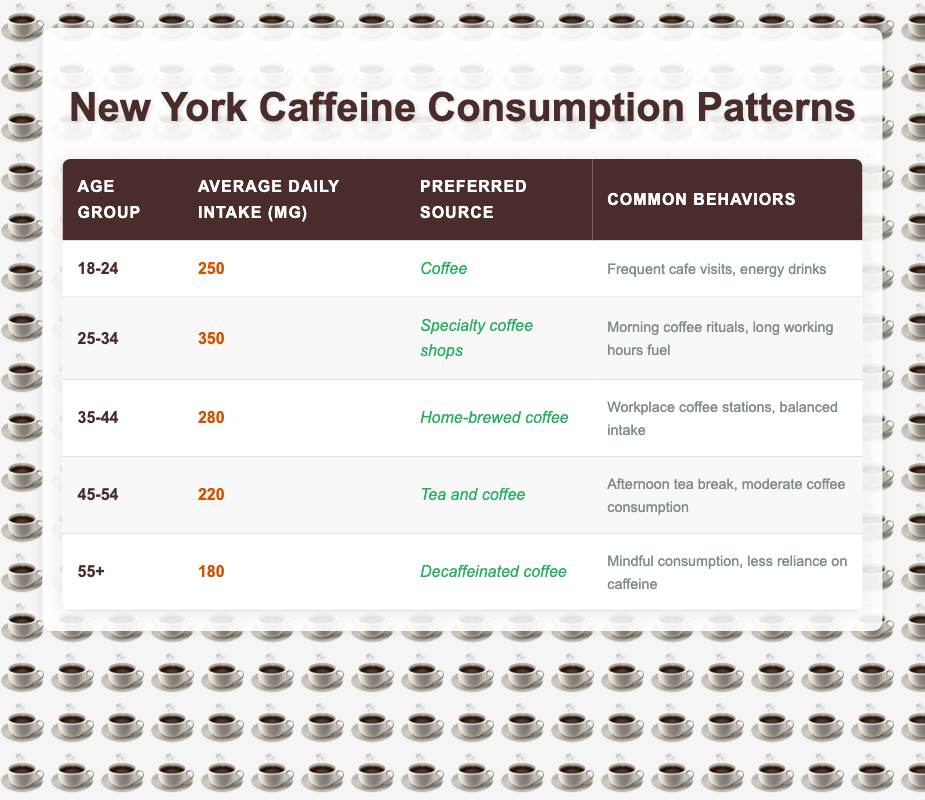What is the average daily intake of caffeine for the age group 25-34? The table lists the average daily intake of caffeine for each age group. For the age group 25-34, the average daily intake is directly stated as 350 mg.
Answer: 350 mg Which age group has the highest average daily intake of caffeine? By examining the table, the age group 25-34 has the highest average daily intake at 350 mg, compared to other age groups that have lower values.
Answer: 25-34 True or False: The preferred source of caffeine for the 18-24 age group is tea. Referring to the table, the preferred source of caffeine for the age group 18-24 is "Coffee," not tea, making this statement false.
Answer: False What is the difference in average daily caffeine intake between the 45-54 and 35-44 age groups? The average daily intake for the age group 45-54 is 220 mg, and for the age group 35-44, it is 280 mg. The difference is calculated as 280 mg - 220 mg = 60 mg.
Answer: 60 mg How many age groups have an average daily caffeine intake below 250 mg? The age groups with average daily intakes below 250 mg are 45-54 (220 mg) and 55+ (180 mg), which totals two age groups.
Answer: 2 What is the average caffeine intake for those aged 55 and older? For the age group 55+, the table states that the average caffeine intake is 180 mg. This is clearly indicated in the data provided.
Answer: 180 mg If we sum the average daily intakes of the 35-44, 45-54, and 55+ age groups, what total do we get? The average daily intakes for these age groups are 280 mg (35-44), 220 mg (45-54), and 180 mg (55+). Summing these gives: 280 + 220 + 180 = 680 mg.
Answer: 680 mg Which age group shows a behavior of "morning coffee rituals"? According to the table, the age group 25-34 displays the behavior described as "Morning coffee rituals."
Answer: 25-34 Is it true that the preferred source of caffeine for individuals aged 35-44 is specialty coffee shops? The table explicitly states that the preferred source for the 35-44 age group is "Home-brewed coffee," therefore the statement is false.
Answer: False 